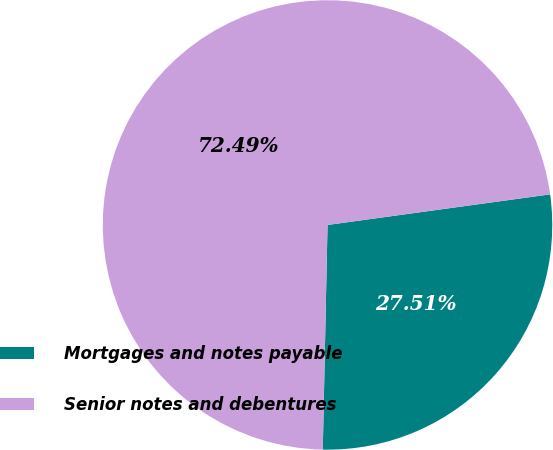<chart> <loc_0><loc_0><loc_500><loc_500><pie_chart><fcel>Mortgages and notes payable<fcel>Senior notes and debentures<nl><fcel>27.51%<fcel>72.49%<nl></chart> 